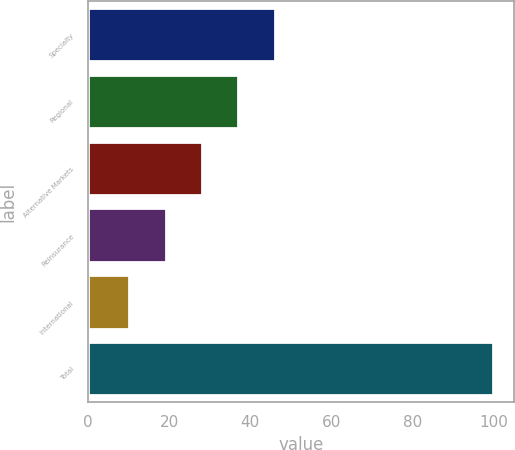Convert chart. <chart><loc_0><loc_0><loc_500><loc_500><bar_chart><fcel>Specialty<fcel>Regional<fcel>Alternative Markets<fcel>Reinsurance<fcel>International<fcel>Total<nl><fcel>46.06<fcel>37.07<fcel>28.08<fcel>19.09<fcel>10.1<fcel>100<nl></chart> 